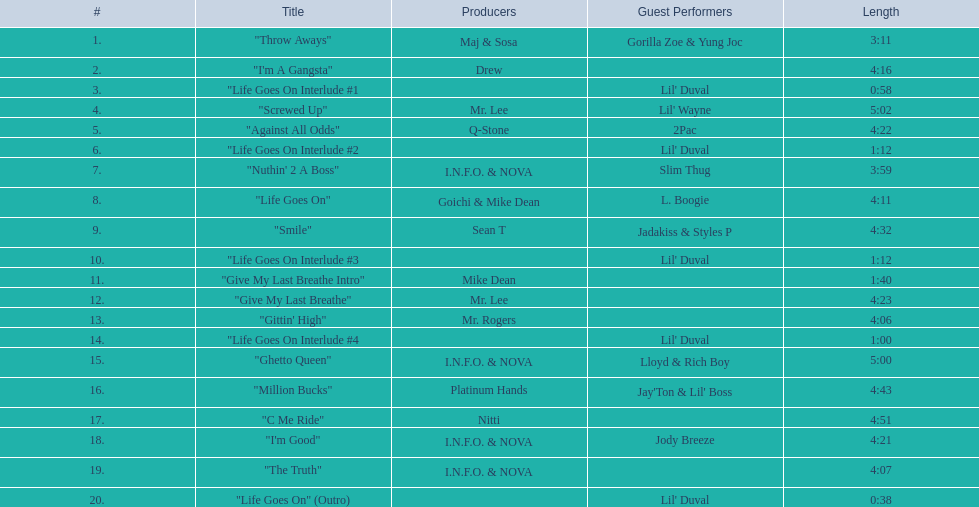What is the number of tracks on trae's "life goes on" album? 20. 